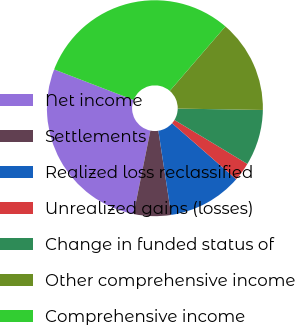Convert chart. <chart><loc_0><loc_0><loc_500><loc_500><pie_chart><fcel>Net income<fcel>Settlements<fcel>Realized loss reclassified<fcel>Unrealized gains (losses)<fcel>Change in funded status of<fcel>Other comprehensive income<fcel>Comprehensive income<nl><fcel>27.68%<fcel>5.58%<fcel>11.15%<fcel>2.8%<fcel>8.37%<fcel>13.94%<fcel>30.47%<nl></chart> 